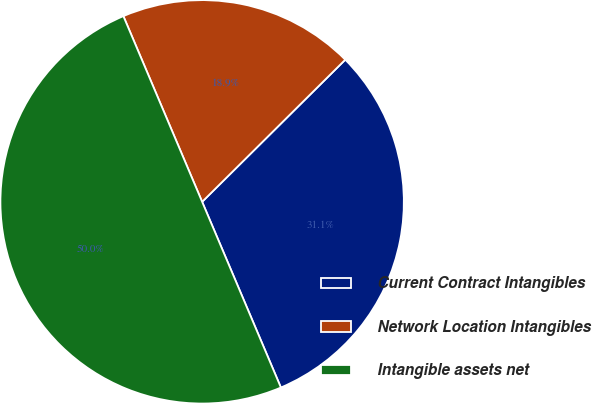Convert chart. <chart><loc_0><loc_0><loc_500><loc_500><pie_chart><fcel>Current Contract Intangibles<fcel>Network Location Intangibles<fcel>Intangible assets net<nl><fcel>31.06%<fcel>18.94%<fcel>50.0%<nl></chart> 